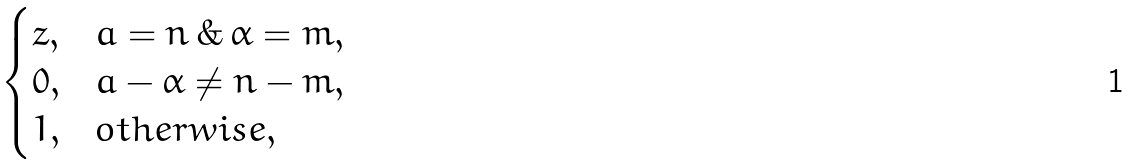Convert formula to latex. <formula><loc_0><loc_0><loc_500><loc_500>\begin{cases} z , & a = n \, \& \, \alpha = m , \\ 0 , & a - \alpha \ne n - m , \\ 1 , & o t h e r w i s e , \end{cases}</formula> 